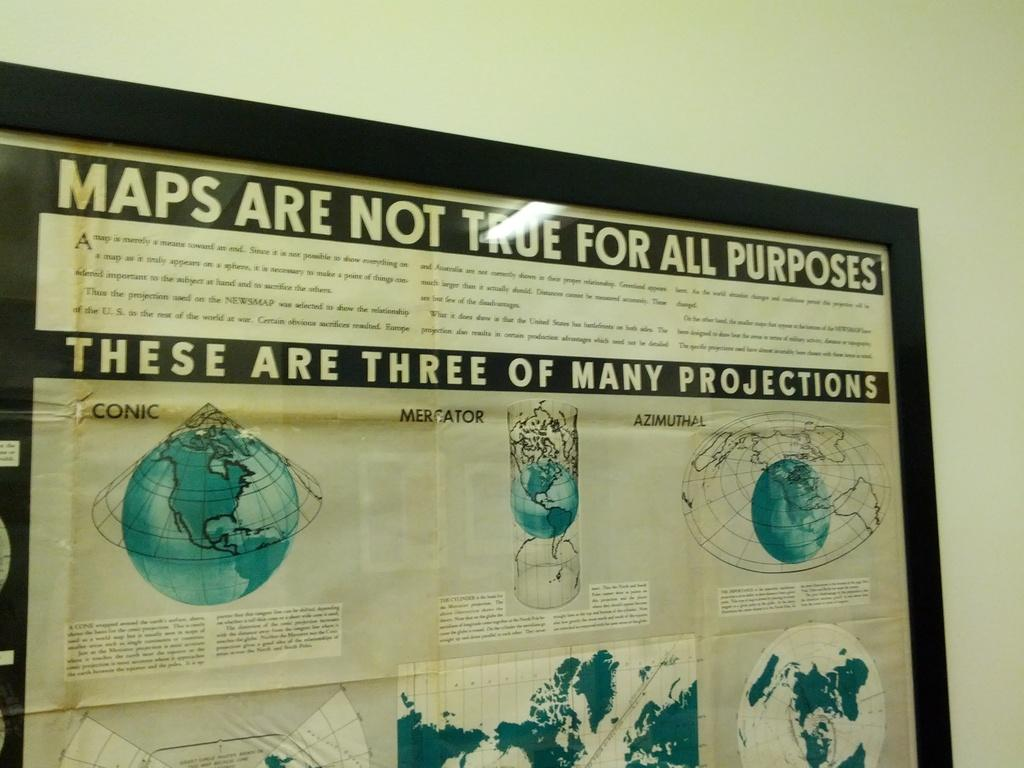Provide a one-sentence caption for the provided image. Maps are not true for all purpose there are three projections in a frame. 